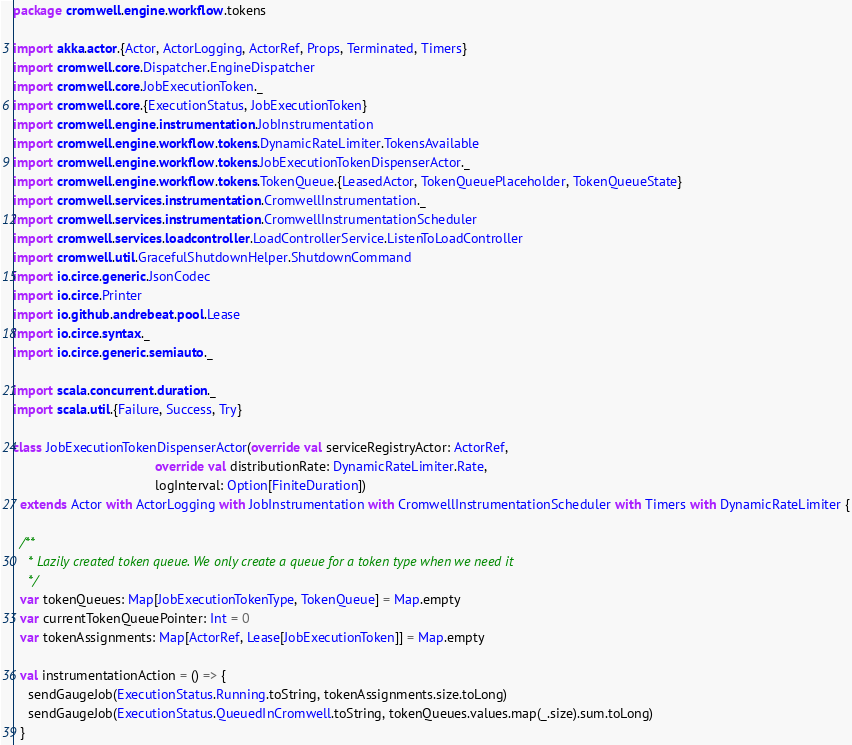<code> <loc_0><loc_0><loc_500><loc_500><_Scala_>package cromwell.engine.workflow.tokens

import akka.actor.{Actor, ActorLogging, ActorRef, Props, Terminated, Timers}
import cromwell.core.Dispatcher.EngineDispatcher
import cromwell.core.JobExecutionToken._
import cromwell.core.{ExecutionStatus, JobExecutionToken}
import cromwell.engine.instrumentation.JobInstrumentation
import cromwell.engine.workflow.tokens.DynamicRateLimiter.TokensAvailable
import cromwell.engine.workflow.tokens.JobExecutionTokenDispenserActor._
import cromwell.engine.workflow.tokens.TokenQueue.{LeasedActor, TokenQueuePlaceholder, TokenQueueState}
import cromwell.services.instrumentation.CromwellInstrumentation._
import cromwell.services.instrumentation.CromwellInstrumentationScheduler
import cromwell.services.loadcontroller.LoadControllerService.ListenToLoadController
import cromwell.util.GracefulShutdownHelper.ShutdownCommand
import io.circe.generic.JsonCodec
import io.circe.Printer
import io.github.andrebeat.pool.Lease
import io.circe.syntax._
import io.circe.generic.semiauto._

import scala.concurrent.duration._
import scala.util.{Failure, Success, Try}

class JobExecutionTokenDispenserActor(override val serviceRegistryActor: ActorRef,
                                      override val distributionRate: DynamicRateLimiter.Rate,
                                      logInterval: Option[FiniteDuration])
  extends Actor with ActorLogging with JobInstrumentation with CromwellInstrumentationScheduler with Timers with DynamicRateLimiter {

  /**
    * Lazily created token queue. We only create a queue for a token type when we need it
    */
  var tokenQueues: Map[JobExecutionTokenType, TokenQueue] = Map.empty
  var currentTokenQueuePointer: Int = 0
  var tokenAssignments: Map[ActorRef, Lease[JobExecutionToken]] = Map.empty

  val instrumentationAction = () => {
    sendGaugeJob(ExecutionStatus.Running.toString, tokenAssignments.size.toLong)
    sendGaugeJob(ExecutionStatus.QueuedInCromwell.toString, tokenQueues.values.map(_.size).sum.toLong)
  }
</code> 